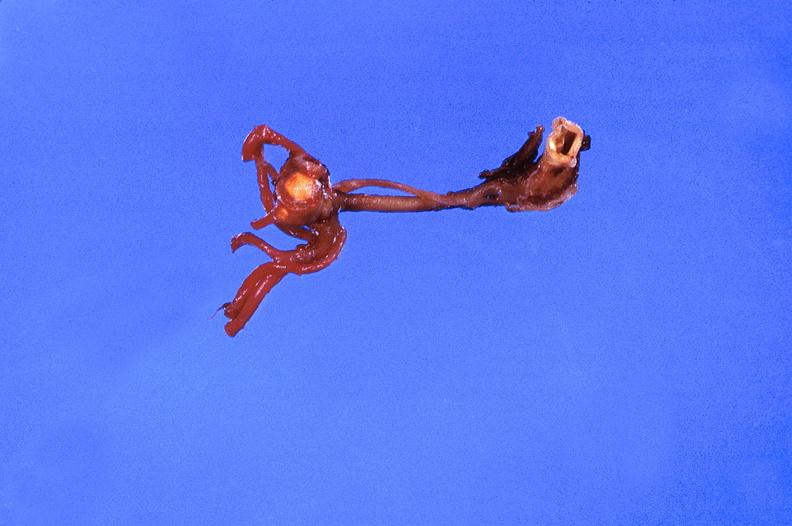does infant body show ruptured saccular aneurysm right middle cerebral artery?
Answer the question using a single word or phrase. No 